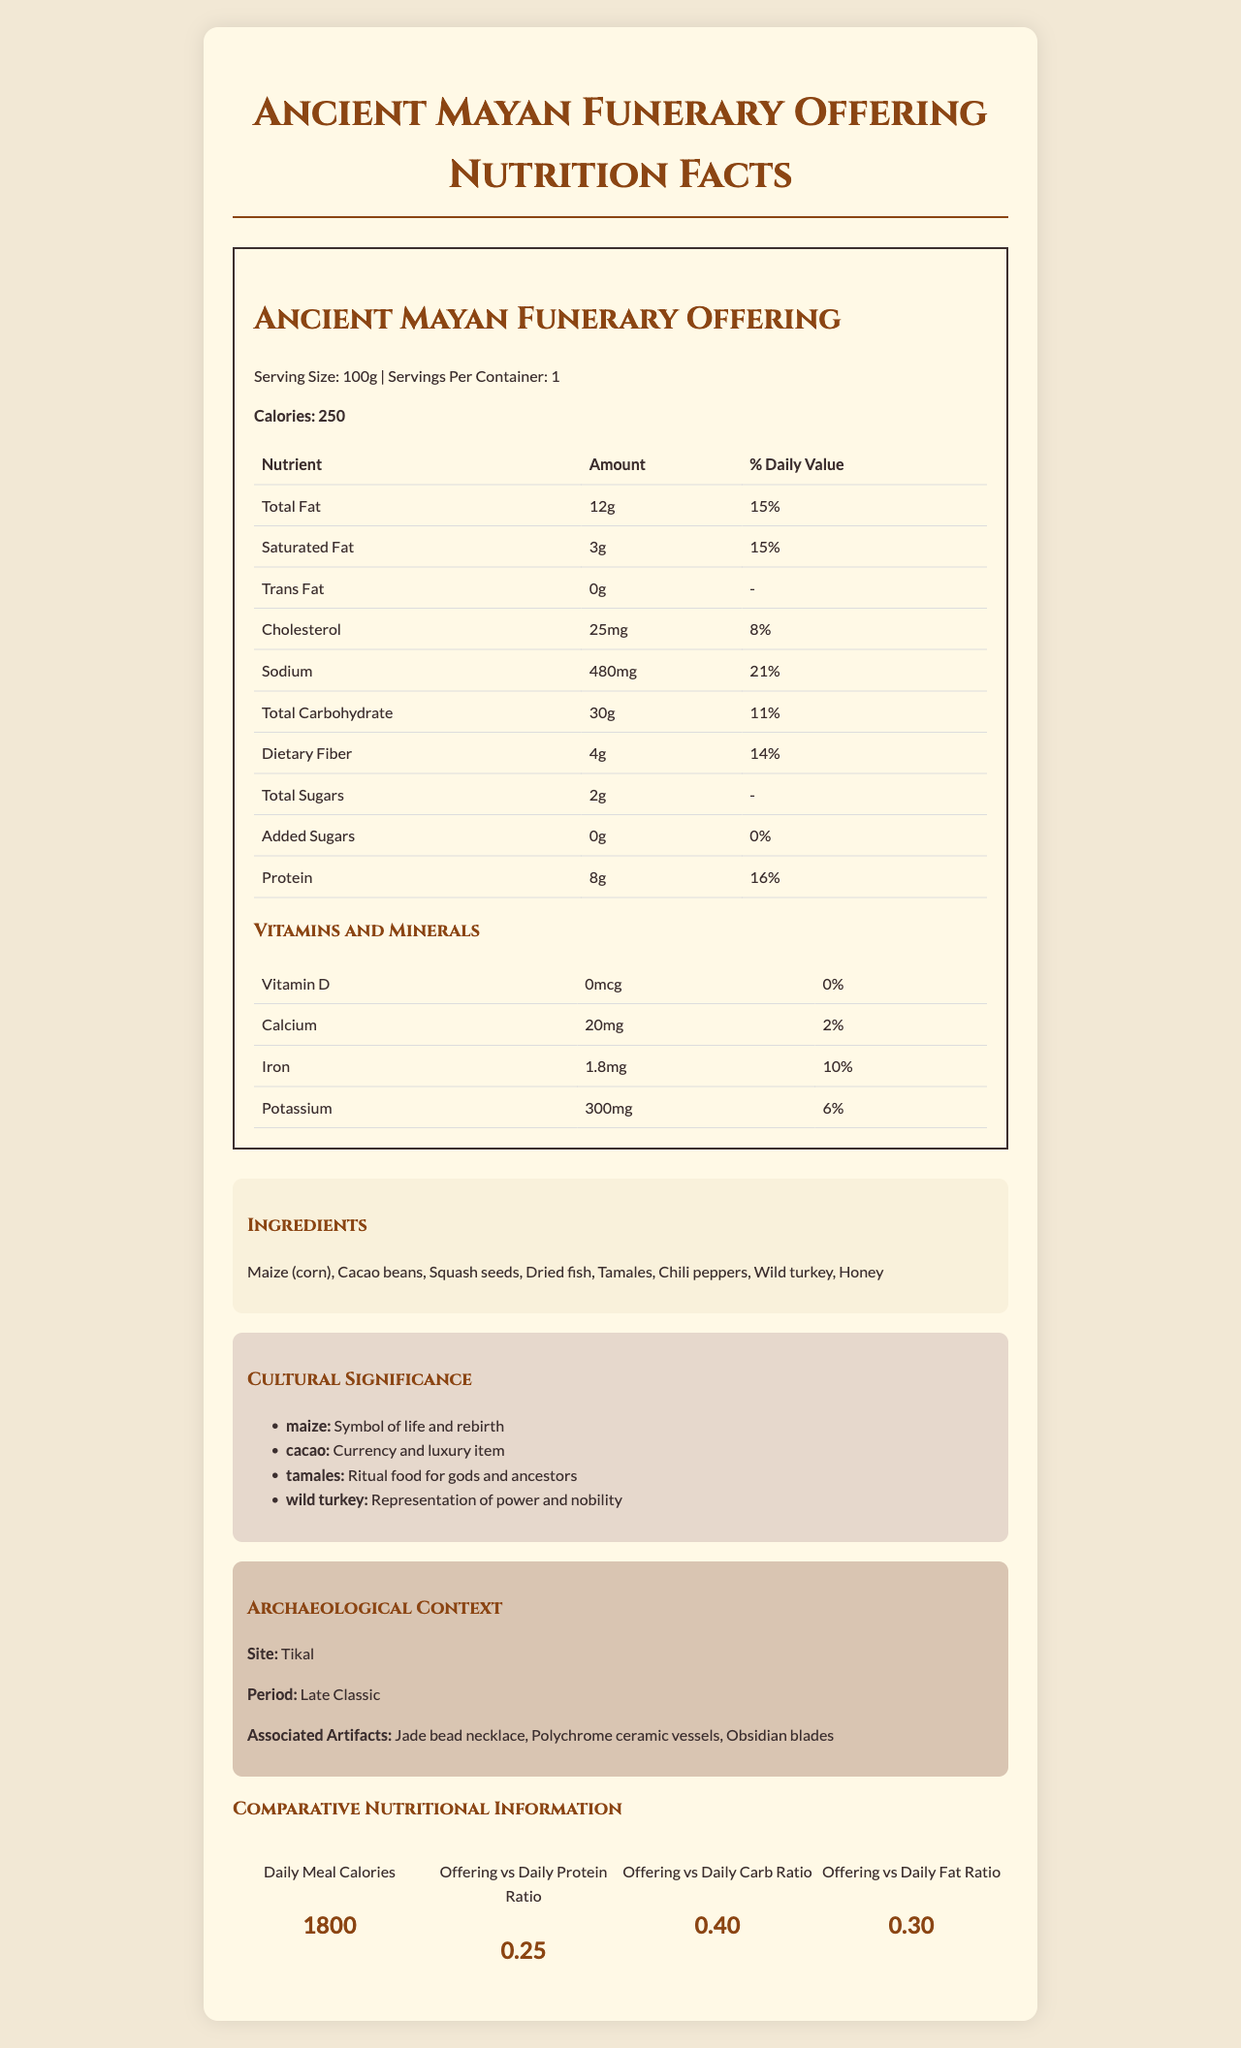what is the serving size of the Ancient Mayan Funerary Offering? The serving size is explicitly mentioned in the document under the nutrition facts.
Answer: 100g what is the period associated with the archaeological context of the offering? The document specifies the period as "Late Classic" under the Archaeological Context section.
Answer: Late Classic how much sodium is in one serving of the offering? The sodium content is shown in the nutrients table.
Answer: 480mg what cultural significance does maize have in the Mayan culture? The document lists the cultural significance of maize under the Cultural Significance section.
Answer: Symbol of life and rebirth list three ingredients found in the Ancient Mayan Funerary Offering. The ingredients section lists these among other ingredients.
Answer: Maize (corn), Cacao beans, Dried fish what is the percentage of daily value for iron in the offering? The percentage of the daily value for iron is listed under the vitamins and minerals section.
Answer: 10% how could the Ancient Mayan Funerary Offering be significant to archaeologists? A. It contains unique artifacts. B. It provides insight into daily consumption. C. It reveals the dietary habits of royalty. The archaeologists could find significance in the unique artifacts listed under associated artifacts like "Jade bead necklace", "Polychrome ceramic vessels", and "Obsidian blades".
Answer: A which nutrient has the highest daily value percentage in the offering? A. Total Fat B. Sodium C. Dietary Fiber D. Protein Sodium has the highest daily value percentage at 21%, as shown in the nutrient table.
Answer: B is the Ancient Mayan Funerary Offering high in added sugars? The document states there are 0g of added sugars and 0% daily value.
Answer: No summarize the main components of the Ancient Mayan Funerary Offering Nutrition Facts document. The summary covers all main sections: nutrition facts, ingredients, cultural significance, archaeological context, and comparative information.
Answer: The document details the nutritional content, ingredients, cultural significance, and archaeological context of the Ancient Mayan Funerary Offering. Specific nutrients and their daily values are listed, alongside the comparative nutritional information with daily meals. what is the exact amount of total carbohydrate in the offering? The exact amount of carbohydrate is mentioned as 30g but it's not clear whether it includes dietary fiber and sugars or just net carbs.
Answer: Cannot be determined what is a unique artifact found at the Tikal site related to the funerary offering? The document lists unique artifacts related to the offering under the Archaeological Context section.
Answer: Jade bead necklace 